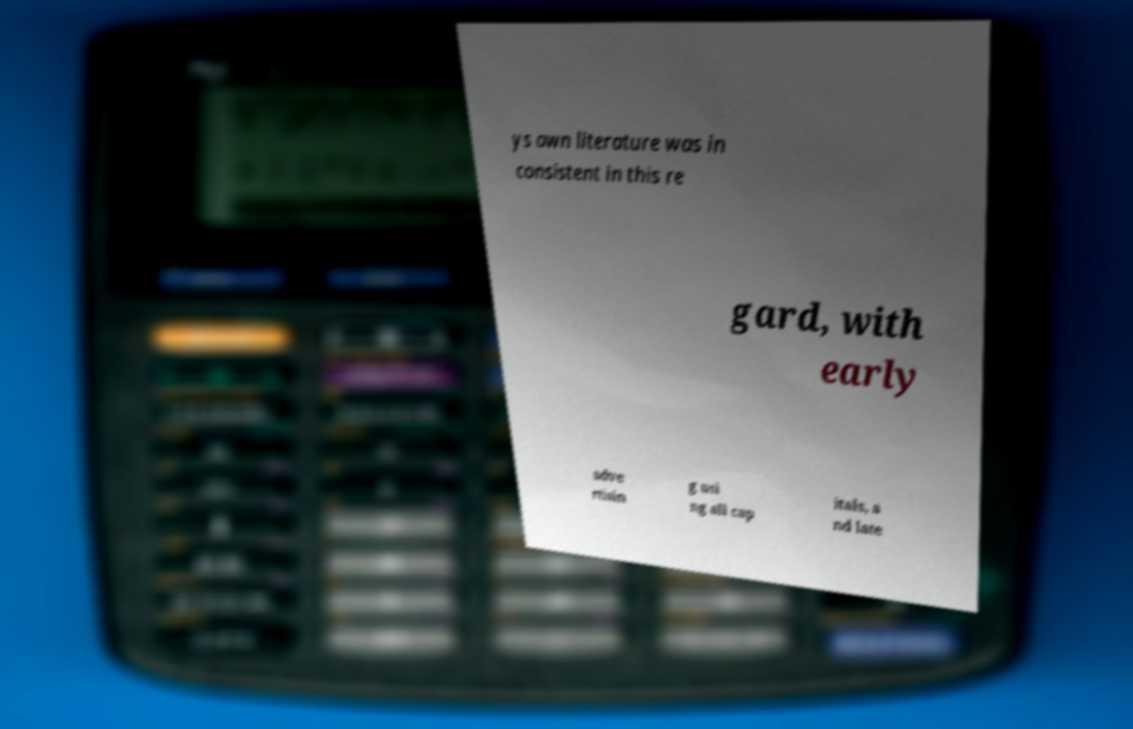Could you assist in decoding the text presented in this image and type it out clearly? ys own literature was in consistent in this re gard, with early adve rtisin g usi ng all cap itals, a nd late 